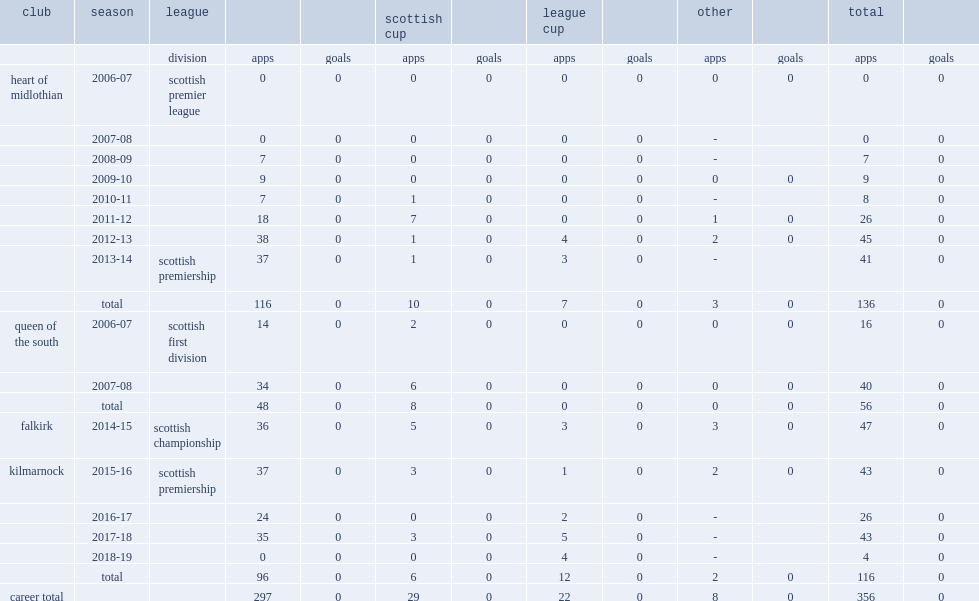Which league did macdonald play the 2014-15 at falkirk? Scottish championship. 